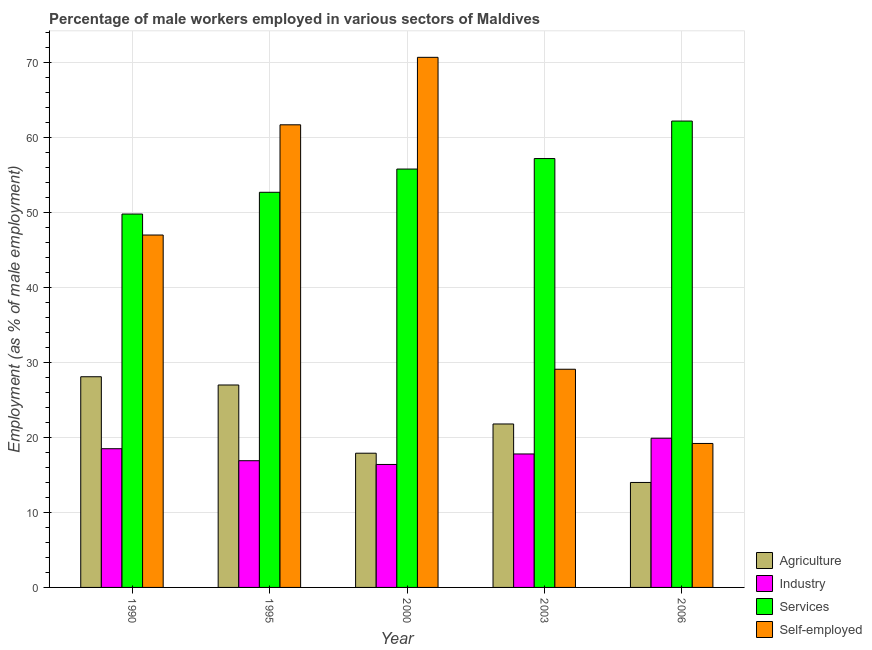How many bars are there on the 2nd tick from the right?
Offer a terse response. 4. In how many cases, is the number of bars for a given year not equal to the number of legend labels?
Offer a terse response. 0. What is the percentage of self employed male workers in 1995?
Your answer should be compact. 61.7. Across all years, what is the maximum percentage of self employed male workers?
Offer a very short reply. 70.7. Across all years, what is the minimum percentage of self employed male workers?
Keep it short and to the point. 19.2. What is the total percentage of male workers in services in the graph?
Offer a very short reply. 277.7. What is the difference between the percentage of male workers in services in 2000 and that in 2006?
Your answer should be compact. -6.4. What is the difference between the percentage of male workers in industry in 1990 and the percentage of self employed male workers in 2000?
Ensure brevity in your answer.  2.1. What is the average percentage of male workers in services per year?
Provide a short and direct response. 55.54. In the year 1995, what is the difference between the percentage of self employed male workers and percentage of male workers in services?
Give a very brief answer. 0. In how many years, is the percentage of male workers in industry greater than 12 %?
Offer a terse response. 5. What is the ratio of the percentage of male workers in services in 1990 to that in 1995?
Your answer should be compact. 0.94. Is the difference between the percentage of male workers in services in 1995 and 2006 greater than the difference between the percentage of self employed male workers in 1995 and 2006?
Your answer should be very brief. No. What is the difference between the highest and the second highest percentage of self employed male workers?
Keep it short and to the point. 9. What is the difference between the highest and the lowest percentage of male workers in services?
Keep it short and to the point. 12.4. In how many years, is the percentage of male workers in agriculture greater than the average percentage of male workers in agriculture taken over all years?
Keep it short and to the point. 3. Is it the case that in every year, the sum of the percentage of male workers in services and percentage of self employed male workers is greater than the sum of percentage of male workers in agriculture and percentage of male workers in industry?
Offer a terse response. No. What does the 4th bar from the left in 1990 represents?
Your response must be concise. Self-employed. What does the 1st bar from the right in 1990 represents?
Your response must be concise. Self-employed. How many bars are there?
Keep it short and to the point. 20. Are all the bars in the graph horizontal?
Offer a very short reply. No. What is the difference between two consecutive major ticks on the Y-axis?
Make the answer very short. 10. Are the values on the major ticks of Y-axis written in scientific E-notation?
Your answer should be compact. No. Does the graph contain any zero values?
Offer a terse response. No. What is the title of the graph?
Offer a terse response. Percentage of male workers employed in various sectors of Maldives. What is the label or title of the X-axis?
Give a very brief answer. Year. What is the label or title of the Y-axis?
Give a very brief answer. Employment (as % of male employment). What is the Employment (as % of male employment) of Agriculture in 1990?
Make the answer very short. 28.1. What is the Employment (as % of male employment) of Services in 1990?
Provide a short and direct response. 49.8. What is the Employment (as % of male employment) of Agriculture in 1995?
Ensure brevity in your answer.  27. What is the Employment (as % of male employment) in Industry in 1995?
Your answer should be very brief. 16.9. What is the Employment (as % of male employment) of Services in 1995?
Ensure brevity in your answer.  52.7. What is the Employment (as % of male employment) of Self-employed in 1995?
Offer a very short reply. 61.7. What is the Employment (as % of male employment) of Agriculture in 2000?
Offer a very short reply. 17.9. What is the Employment (as % of male employment) of Industry in 2000?
Your response must be concise. 16.4. What is the Employment (as % of male employment) of Services in 2000?
Your response must be concise. 55.8. What is the Employment (as % of male employment) of Self-employed in 2000?
Provide a short and direct response. 70.7. What is the Employment (as % of male employment) in Agriculture in 2003?
Make the answer very short. 21.8. What is the Employment (as % of male employment) in Industry in 2003?
Your answer should be very brief. 17.8. What is the Employment (as % of male employment) of Services in 2003?
Your response must be concise. 57.2. What is the Employment (as % of male employment) in Self-employed in 2003?
Your answer should be very brief. 29.1. What is the Employment (as % of male employment) of Industry in 2006?
Make the answer very short. 19.9. What is the Employment (as % of male employment) in Services in 2006?
Your answer should be very brief. 62.2. What is the Employment (as % of male employment) of Self-employed in 2006?
Provide a short and direct response. 19.2. Across all years, what is the maximum Employment (as % of male employment) in Agriculture?
Make the answer very short. 28.1. Across all years, what is the maximum Employment (as % of male employment) in Industry?
Ensure brevity in your answer.  19.9. Across all years, what is the maximum Employment (as % of male employment) in Services?
Make the answer very short. 62.2. Across all years, what is the maximum Employment (as % of male employment) in Self-employed?
Ensure brevity in your answer.  70.7. Across all years, what is the minimum Employment (as % of male employment) of Industry?
Keep it short and to the point. 16.4. Across all years, what is the minimum Employment (as % of male employment) in Services?
Provide a succinct answer. 49.8. Across all years, what is the minimum Employment (as % of male employment) of Self-employed?
Keep it short and to the point. 19.2. What is the total Employment (as % of male employment) of Agriculture in the graph?
Keep it short and to the point. 108.8. What is the total Employment (as % of male employment) of Industry in the graph?
Your answer should be compact. 89.5. What is the total Employment (as % of male employment) in Services in the graph?
Provide a succinct answer. 277.7. What is the total Employment (as % of male employment) in Self-employed in the graph?
Give a very brief answer. 227.7. What is the difference between the Employment (as % of male employment) of Agriculture in 1990 and that in 1995?
Make the answer very short. 1.1. What is the difference between the Employment (as % of male employment) in Services in 1990 and that in 1995?
Provide a short and direct response. -2.9. What is the difference between the Employment (as % of male employment) of Self-employed in 1990 and that in 1995?
Provide a succinct answer. -14.7. What is the difference between the Employment (as % of male employment) in Agriculture in 1990 and that in 2000?
Keep it short and to the point. 10.2. What is the difference between the Employment (as % of male employment) of Industry in 1990 and that in 2000?
Ensure brevity in your answer.  2.1. What is the difference between the Employment (as % of male employment) of Self-employed in 1990 and that in 2000?
Your answer should be compact. -23.7. What is the difference between the Employment (as % of male employment) in Agriculture in 1990 and that in 2006?
Provide a short and direct response. 14.1. What is the difference between the Employment (as % of male employment) in Industry in 1990 and that in 2006?
Ensure brevity in your answer.  -1.4. What is the difference between the Employment (as % of male employment) of Self-employed in 1990 and that in 2006?
Ensure brevity in your answer.  27.8. What is the difference between the Employment (as % of male employment) of Services in 1995 and that in 2000?
Keep it short and to the point. -3.1. What is the difference between the Employment (as % of male employment) in Agriculture in 1995 and that in 2003?
Offer a very short reply. 5.2. What is the difference between the Employment (as % of male employment) of Services in 1995 and that in 2003?
Offer a very short reply. -4.5. What is the difference between the Employment (as % of male employment) in Self-employed in 1995 and that in 2003?
Provide a short and direct response. 32.6. What is the difference between the Employment (as % of male employment) in Agriculture in 1995 and that in 2006?
Keep it short and to the point. 13. What is the difference between the Employment (as % of male employment) of Industry in 1995 and that in 2006?
Provide a short and direct response. -3. What is the difference between the Employment (as % of male employment) in Self-employed in 1995 and that in 2006?
Make the answer very short. 42.5. What is the difference between the Employment (as % of male employment) in Agriculture in 2000 and that in 2003?
Ensure brevity in your answer.  -3.9. What is the difference between the Employment (as % of male employment) of Industry in 2000 and that in 2003?
Provide a succinct answer. -1.4. What is the difference between the Employment (as % of male employment) in Self-employed in 2000 and that in 2003?
Provide a succinct answer. 41.6. What is the difference between the Employment (as % of male employment) in Industry in 2000 and that in 2006?
Provide a short and direct response. -3.5. What is the difference between the Employment (as % of male employment) of Self-employed in 2000 and that in 2006?
Offer a very short reply. 51.5. What is the difference between the Employment (as % of male employment) in Agriculture in 1990 and the Employment (as % of male employment) in Industry in 1995?
Offer a terse response. 11.2. What is the difference between the Employment (as % of male employment) of Agriculture in 1990 and the Employment (as % of male employment) of Services in 1995?
Give a very brief answer. -24.6. What is the difference between the Employment (as % of male employment) of Agriculture in 1990 and the Employment (as % of male employment) of Self-employed in 1995?
Your answer should be compact. -33.6. What is the difference between the Employment (as % of male employment) of Industry in 1990 and the Employment (as % of male employment) of Services in 1995?
Offer a terse response. -34.2. What is the difference between the Employment (as % of male employment) in Industry in 1990 and the Employment (as % of male employment) in Self-employed in 1995?
Give a very brief answer. -43.2. What is the difference between the Employment (as % of male employment) of Agriculture in 1990 and the Employment (as % of male employment) of Services in 2000?
Ensure brevity in your answer.  -27.7. What is the difference between the Employment (as % of male employment) of Agriculture in 1990 and the Employment (as % of male employment) of Self-employed in 2000?
Ensure brevity in your answer.  -42.6. What is the difference between the Employment (as % of male employment) in Industry in 1990 and the Employment (as % of male employment) in Services in 2000?
Give a very brief answer. -37.3. What is the difference between the Employment (as % of male employment) of Industry in 1990 and the Employment (as % of male employment) of Self-employed in 2000?
Ensure brevity in your answer.  -52.2. What is the difference between the Employment (as % of male employment) in Services in 1990 and the Employment (as % of male employment) in Self-employed in 2000?
Your response must be concise. -20.9. What is the difference between the Employment (as % of male employment) of Agriculture in 1990 and the Employment (as % of male employment) of Services in 2003?
Offer a very short reply. -29.1. What is the difference between the Employment (as % of male employment) of Industry in 1990 and the Employment (as % of male employment) of Services in 2003?
Your answer should be compact. -38.7. What is the difference between the Employment (as % of male employment) of Services in 1990 and the Employment (as % of male employment) of Self-employed in 2003?
Make the answer very short. 20.7. What is the difference between the Employment (as % of male employment) of Agriculture in 1990 and the Employment (as % of male employment) of Services in 2006?
Provide a short and direct response. -34.1. What is the difference between the Employment (as % of male employment) in Industry in 1990 and the Employment (as % of male employment) in Services in 2006?
Offer a terse response. -43.7. What is the difference between the Employment (as % of male employment) in Industry in 1990 and the Employment (as % of male employment) in Self-employed in 2006?
Your response must be concise. -0.7. What is the difference between the Employment (as % of male employment) in Services in 1990 and the Employment (as % of male employment) in Self-employed in 2006?
Provide a succinct answer. 30.6. What is the difference between the Employment (as % of male employment) in Agriculture in 1995 and the Employment (as % of male employment) in Services in 2000?
Offer a terse response. -28.8. What is the difference between the Employment (as % of male employment) of Agriculture in 1995 and the Employment (as % of male employment) of Self-employed in 2000?
Make the answer very short. -43.7. What is the difference between the Employment (as % of male employment) of Industry in 1995 and the Employment (as % of male employment) of Services in 2000?
Your answer should be very brief. -38.9. What is the difference between the Employment (as % of male employment) in Industry in 1995 and the Employment (as % of male employment) in Self-employed in 2000?
Offer a very short reply. -53.8. What is the difference between the Employment (as % of male employment) in Agriculture in 1995 and the Employment (as % of male employment) in Industry in 2003?
Keep it short and to the point. 9.2. What is the difference between the Employment (as % of male employment) of Agriculture in 1995 and the Employment (as % of male employment) of Services in 2003?
Your answer should be compact. -30.2. What is the difference between the Employment (as % of male employment) in Agriculture in 1995 and the Employment (as % of male employment) in Self-employed in 2003?
Your response must be concise. -2.1. What is the difference between the Employment (as % of male employment) in Industry in 1995 and the Employment (as % of male employment) in Services in 2003?
Offer a very short reply. -40.3. What is the difference between the Employment (as % of male employment) of Services in 1995 and the Employment (as % of male employment) of Self-employed in 2003?
Ensure brevity in your answer.  23.6. What is the difference between the Employment (as % of male employment) in Agriculture in 1995 and the Employment (as % of male employment) in Industry in 2006?
Provide a short and direct response. 7.1. What is the difference between the Employment (as % of male employment) in Agriculture in 1995 and the Employment (as % of male employment) in Services in 2006?
Ensure brevity in your answer.  -35.2. What is the difference between the Employment (as % of male employment) of Industry in 1995 and the Employment (as % of male employment) of Services in 2006?
Ensure brevity in your answer.  -45.3. What is the difference between the Employment (as % of male employment) of Industry in 1995 and the Employment (as % of male employment) of Self-employed in 2006?
Keep it short and to the point. -2.3. What is the difference between the Employment (as % of male employment) of Services in 1995 and the Employment (as % of male employment) of Self-employed in 2006?
Ensure brevity in your answer.  33.5. What is the difference between the Employment (as % of male employment) of Agriculture in 2000 and the Employment (as % of male employment) of Industry in 2003?
Ensure brevity in your answer.  0.1. What is the difference between the Employment (as % of male employment) in Agriculture in 2000 and the Employment (as % of male employment) in Services in 2003?
Offer a terse response. -39.3. What is the difference between the Employment (as % of male employment) in Industry in 2000 and the Employment (as % of male employment) in Services in 2003?
Offer a terse response. -40.8. What is the difference between the Employment (as % of male employment) in Industry in 2000 and the Employment (as % of male employment) in Self-employed in 2003?
Offer a very short reply. -12.7. What is the difference between the Employment (as % of male employment) of Services in 2000 and the Employment (as % of male employment) of Self-employed in 2003?
Ensure brevity in your answer.  26.7. What is the difference between the Employment (as % of male employment) of Agriculture in 2000 and the Employment (as % of male employment) of Services in 2006?
Make the answer very short. -44.3. What is the difference between the Employment (as % of male employment) of Agriculture in 2000 and the Employment (as % of male employment) of Self-employed in 2006?
Your answer should be compact. -1.3. What is the difference between the Employment (as % of male employment) of Industry in 2000 and the Employment (as % of male employment) of Services in 2006?
Provide a short and direct response. -45.8. What is the difference between the Employment (as % of male employment) of Services in 2000 and the Employment (as % of male employment) of Self-employed in 2006?
Ensure brevity in your answer.  36.6. What is the difference between the Employment (as % of male employment) of Agriculture in 2003 and the Employment (as % of male employment) of Industry in 2006?
Provide a succinct answer. 1.9. What is the difference between the Employment (as % of male employment) of Agriculture in 2003 and the Employment (as % of male employment) of Services in 2006?
Your response must be concise. -40.4. What is the difference between the Employment (as % of male employment) of Industry in 2003 and the Employment (as % of male employment) of Services in 2006?
Make the answer very short. -44.4. What is the average Employment (as % of male employment) in Agriculture per year?
Ensure brevity in your answer.  21.76. What is the average Employment (as % of male employment) in Industry per year?
Your answer should be compact. 17.9. What is the average Employment (as % of male employment) of Services per year?
Offer a very short reply. 55.54. What is the average Employment (as % of male employment) of Self-employed per year?
Give a very brief answer. 45.54. In the year 1990, what is the difference between the Employment (as % of male employment) in Agriculture and Employment (as % of male employment) in Industry?
Provide a succinct answer. 9.6. In the year 1990, what is the difference between the Employment (as % of male employment) in Agriculture and Employment (as % of male employment) in Services?
Offer a terse response. -21.7. In the year 1990, what is the difference between the Employment (as % of male employment) of Agriculture and Employment (as % of male employment) of Self-employed?
Ensure brevity in your answer.  -18.9. In the year 1990, what is the difference between the Employment (as % of male employment) of Industry and Employment (as % of male employment) of Services?
Your answer should be compact. -31.3. In the year 1990, what is the difference between the Employment (as % of male employment) in Industry and Employment (as % of male employment) in Self-employed?
Provide a short and direct response. -28.5. In the year 1995, what is the difference between the Employment (as % of male employment) of Agriculture and Employment (as % of male employment) of Industry?
Offer a terse response. 10.1. In the year 1995, what is the difference between the Employment (as % of male employment) in Agriculture and Employment (as % of male employment) in Services?
Your response must be concise. -25.7. In the year 1995, what is the difference between the Employment (as % of male employment) in Agriculture and Employment (as % of male employment) in Self-employed?
Offer a terse response. -34.7. In the year 1995, what is the difference between the Employment (as % of male employment) in Industry and Employment (as % of male employment) in Services?
Ensure brevity in your answer.  -35.8. In the year 1995, what is the difference between the Employment (as % of male employment) in Industry and Employment (as % of male employment) in Self-employed?
Your answer should be very brief. -44.8. In the year 1995, what is the difference between the Employment (as % of male employment) of Services and Employment (as % of male employment) of Self-employed?
Your answer should be very brief. -9. In the year 2000, what is the difference between the Employment (as % of male employment) of Agriculture and Employment (as % of male employment) of Industry?
Your answer should be very brief. 1.5. In the year 2000, what is the difference between the Employment (as % of male employment) of Agriculture and Employment (as % of male employment) of Services?
Your answer should be very brief. -37.9. In the year 2000, what is the difference between the Employment (as % of male employment) in Agriculture and Employment (as % of male employment) in Self-employed?
Provide a short and direct response. -52.8. In the year 2000, what is the difference between the Employment (as % of male employment) in Industry and Employment (as % of male employment) in Services?
Your answer should be compact. -39.4. In the year 2000, what is the difference between the Employment (as % of male employment) in Industry and Employment (as % of male employment) in Self-employed?
Provide a succinct answer. -54.3. In the year 2000, what is the difference between the Employment (as % of male employment) in Services and Employment (as % of male employment) in Self-employed?
Offer a very short reply. -14.9. In the year 2003, what is the difference between the Employment (as % of male employment) in Agriculture and Employment (as % of male employment) in Industry?
Offer a very short reply. 4. In the year 2003, what is the difference between the Employment (as % of male employment) in Agriculture and Employment (as % of male employment) in Services?
Provide a succinct answer. -35.4. In the year 2003, what is the difference between the Employment (as % of male employment) in Agriculture and Employment (as % of male employment) in Self-employed?
Keep it short and to the point. -7.3. In the year 2003, what is the difference between the Employment (as % of male employment) of Industry and Employment (as % of male employment) of Services?
Ensure brevity in your answer.  -39.4. In the year 2003, what is the difference between the Employment (as % of male employment) of Services and Employment (as % of male employment) of Self-employed?
Make the answer very short. 28.1. In the year 2006, what is the difference between the Employment (as % of male employment) in Agriculture and Employment (as % of male employment) in Services?
Keep it short and to the point. -48.2. In the year 2006, what is the difference between the Employment (as % of male employment) of Industry and Employment (as % of male employment) of Services?
Provide a short and direct response. -42.3. In the year 2006, what is the difference between the Employment (as % of male employment) in Industry and Employment (as % of male employment) in Self-employed?
Provide a succinct answer. 0.7. What is the ratio of the Employment (as % of male employment) of Agriculture in 1990 to that in 1995?
Your answer should be compact. 1.04. What is the ratio of the Employment (as % of male employment) in Industry in 1990 to that in 1995?
Ensure brevity in your answer.  1.09. What is the ratio of the Employment (as % of male employment) of Services in 1990 to that in 1995?
Offer a very short reply. 0.94. What is the ratio of the Employment (as % of male employment) in Self-employed in 1990 to that in 1995?
Ensure brevity in your answer.  0.76. What is the ratio of the Employment (as % of male employment) in Agriculture in 1990 to that in 2000?
Keep it short and to the point. 1.57. What is the ratio of the Employment (as % of male employment) in Industry in 1990 to that in 2000?
Ensure brevity in your answer.  1.13. What is the ratio of the Employment (as % of male employment) in Services in 1990 to that in 2000?
Ensure brevity in your answer.  0.89. What is the ratio of the Employment (as % of male employment) in Self-employed in 1990 to that in 2000?
Your response must be concise. 0.66. What is the ratio of the Employment (as % of male employment) in Agriculture in 1990 to that in 2003?
Your answer should be compact. 1.29. What is the ratio of the Employment (as % of male employment) in Industry in 1990 to that in 2003?
Keep it short and to the point. 1.04. What is the ratio of the Employment (as % of male employment) of Services in 1990 to that in 2003?
Ensure brevity in your answer.  0.87. What is the ratio of the Employment (as % of male employment) in Self-employed in 1990 to that in 2003?
Keep it short and to the point. 1.62. What is the ratio of the Employment (as % of male employment) in Agriculture in 1990 to that in 2006?
Your answer should be compact. 2.01. What is the ratio of the Employment (as % of male employment) in Industry in 1990 to that in 2006?
Offer a terse response. 0.93. What is the ratio of the Employment (as % of male employment) of Services in 1990 to that in 2006?
Your answer should be very brief. 0.8. What is the ratio of the Employment (as % of male employment) in Self-employed in 1990 to that in 2006?
Ensure brevity in your answer.  2.45. What is the ratio of the Employment (as % of male employment) of Agriculture in 1995 to that in 2000?
Make the answer very short. 1.51. What is the ratio of the Employment (as % of male employment) of Industry in 1995 to that in 2000?
Provide a succinct answer. 1.03. What is the ratio of the Employment (as % of male employment) of Self-employed in 1995 to that in 2000?
Offer a very short reply. 0.87. What is the ratio of the Employment (as % of male employment) in Agriculture in 1995 to that in 2003?
Your answer should be compact. 1.24. What is the ratio of the Employment (as % of male employment) in Industry in 1995 to that in 2003?
Provide a short and direct response. 0.95. What is the ratio of the Employment (as % of male employment) of Services in 1995 to that in 2003?
Provide a succinct answer. 0.92. What is the ratio of the Employment (as % of male employment) of Self-employed in 1995 to that in 2003?
Provide a succinct answer. 2.12. What is the ratio of the Employment (as % of male employment) in Agriculture in 1995 to that in 2006?
Provide a succinct answer. 1.93. What is the ratio of the Employment (as % of male employment) of Industry in 1995 to that in 2006?
Make the answer very short. 0.85. What is the ratio of the Employment (as % of male employment) in Services in 1995 to that in 2006?
Provide a short and direct response. 0.85. What is the ratio of the Employment (as % of male employment) in Self-employed in 1995 to that in 2006?
Provide a short and direct response. 3.21. What is the ratio of the Employment (as % of male employment) of Agriculture in 2000 to that in 2003?
Your response must be concise. 0.82. What is the ratio of the Employment (as % of male employment) of Industry in 2000 to that in 2003?
Provide a succinct answer. 0.92. What is the ratio of the Employment (as % of male employment) in Services in 2000 to that in 2003?
Ensure brevity in your answer.  0.98. What is the ratio of the Employment (as % of male employment) in Self-employed in 2000 to that in 2003?
Ensure brevity in your answer.  2.43. What is the ratio of the Employment (as % of male employment) of Agriculture in 2000 to that in 2006?
Your answer should be compact. 1.28. What is the ratio of the Employment (as % of male employment) in Industry in 2000 to that in 2006?
Give a very brief answer. 0.82. What is the ratio of the Employment (as % of male employment) of Services in 2000 to that in 2006?
Keep it short and to the point. 0.9. What is the ratio of the Employment (as % of male employment) of Self-employed in 2000 to that in 2006?
Give a very brief answer. 3.68. What is the ratio of the Employment (as % of male employment) in Agriculture in 2003 to that in 2006?
Provide a succinct answer. 1.56. What is the ratio of the Employment (as % of male employment) in Industry in 2003 to that in 2006?
Your answer should be very brief. 0.89. What is the ratio of the Employment (as % of male employment) in Services in 2003 to that in 2006?
Your answer should be very brief. 0.92. What is the ratio of the Employment (as % of male employment) in Self-employed in 2003 to that in 2006?
Offer a terse response. 1.52. What is the difference between the highest and the second highest Employment (as % of male employment) in Agriculture?
Give a very brief answer. 1.1. What is the difference between the highest and the second highest Employment (as % of male employment) in Self-employed?
Offer a terse response. 9. What is the difference between the highest and the lowest Employment (as % of male employment) of Industry?
Offer a terse response. 3.5. What is the difference between the highest and the lowest Employment (as % of male employment) of Services?
Your response must be concise. 12.4. What is the difference between the highest and the lowest Employment (as % of male employment) in Self-employed?
Give a very brief answer. 51.5. 